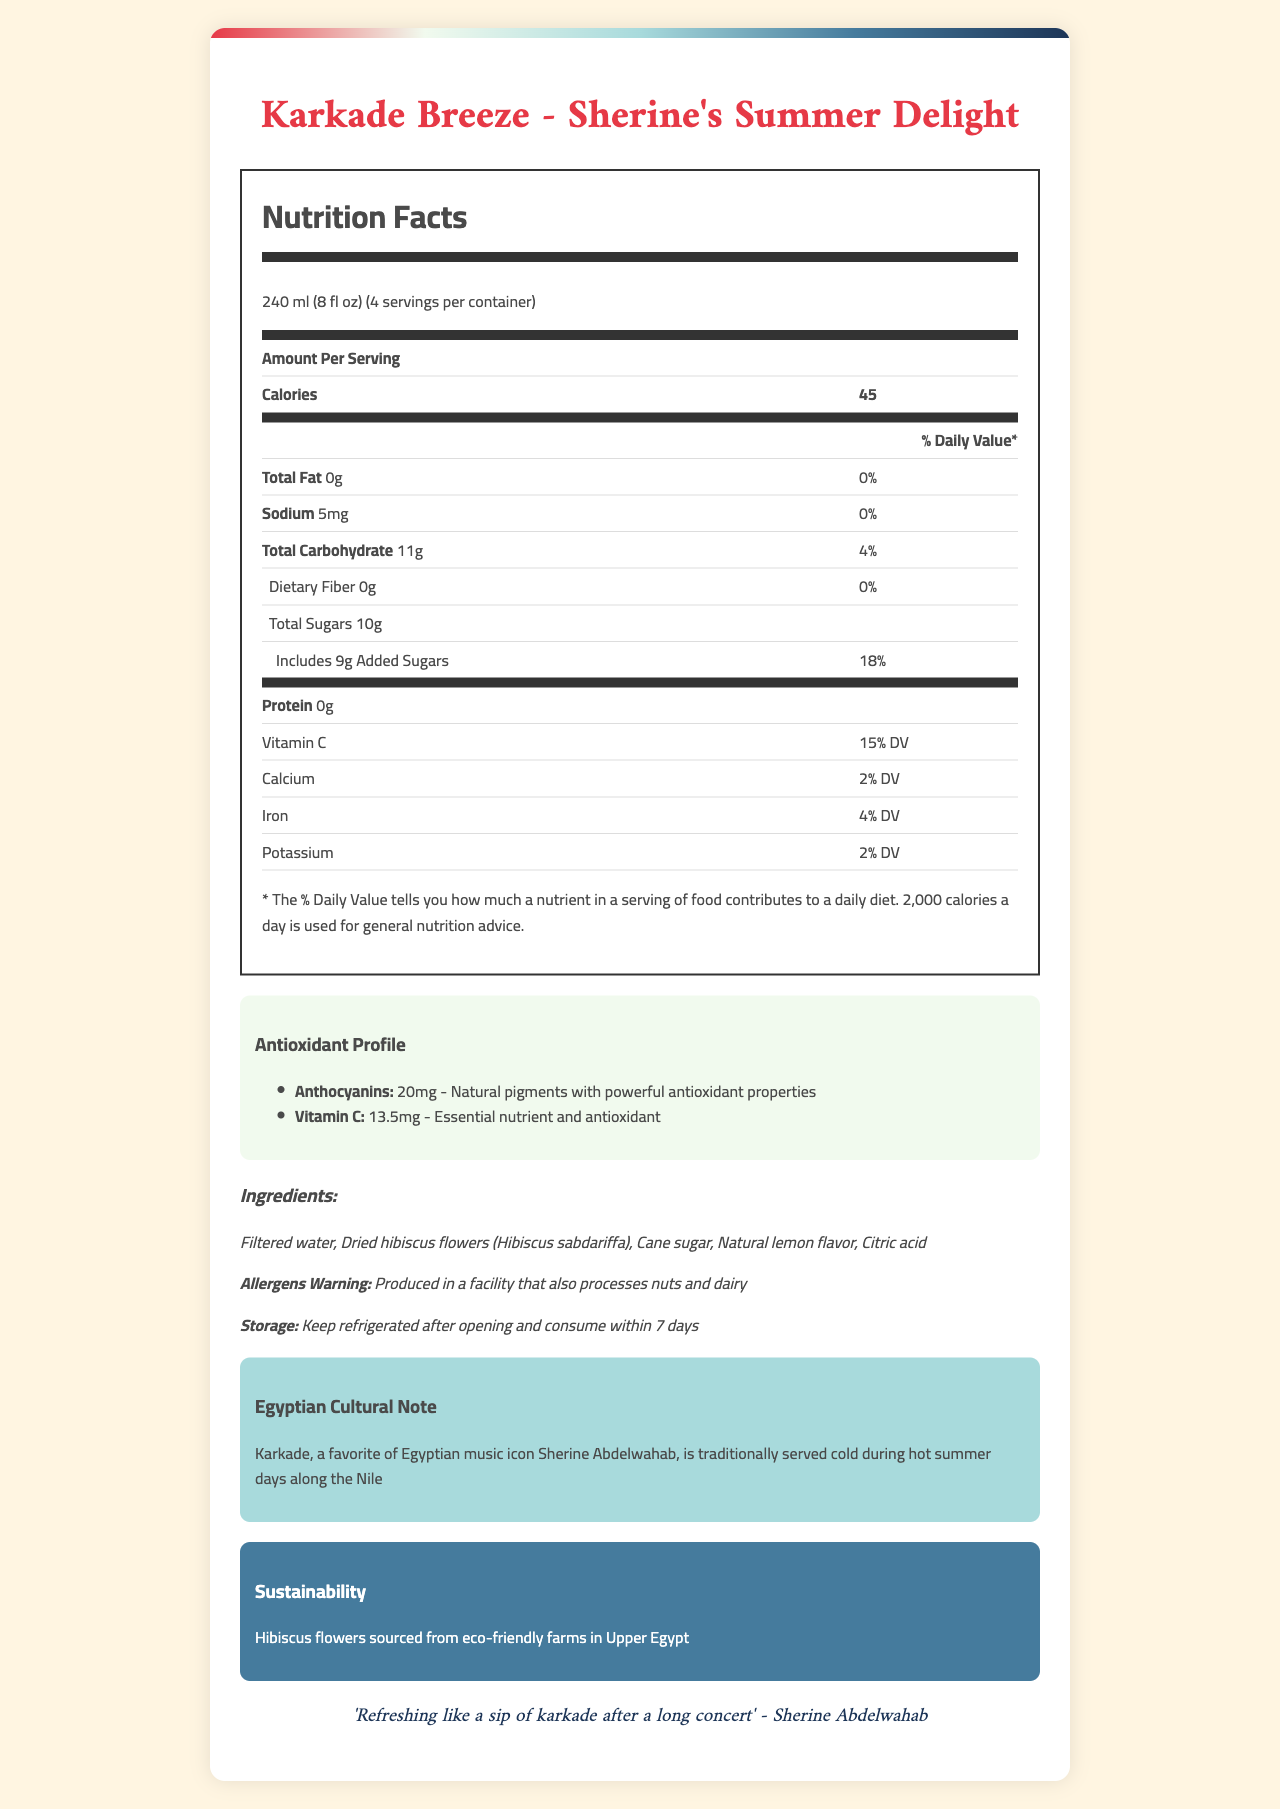What is the serving size of "Karkade Breeze - Sherine's Summer Delight"? The serving size is explicitly mentioned at the top of the Nutrition Facts table.
Answer: 240 ml (8 fl oz) How many calories are there per serving? The calories per serving are listed as 45.
Answer: 45 What percentage of the daily value of Vitamin C is in one serving? The Nutrition Facts list 15% DV for Vitamin C per serving.
Answer: 15% What are the main antioxidants found in "Karkade Breeze - Sherine's Summer Delight"? The 'Antioxidant Profile' section highlights Anthocyanins and Vitamin C.
Answer: Anthocyanins and Vitamin C How many grams of total sugars are in one serving? The Nutrition Facts table lists 10g under 'Total Sugars'.
Answer: 10g What are the ingredients of "Karkade Breeze - Sherine's Summer Delight"? The Ingredients section provides this detailed list.
Answer: Filtered water, Dried hibiscus flowers (Hibiscus sabdariffa), Cane sugar, Natural lemon flavor, Citric acid Does the product contain any protein? The Nutrition Facts state that the product contains 0g protein.
Answer: No What is the recommended storage instruction for the product? The storage instructions mention keeping the product refrigerated and consuming within 7 days of opening.
Answer: Keep refrigerated after opening and consume within 7 days Who is mentioned in the Egyptian Cultural Note as having a preference for karkade? The Egyptian Cultural Note specifically mentions Egyptian music icon Sherine Abdelwahab.
Answer: Sherine Abdelwahab What is the primary source of the hibiscus flowers used in the product? The Sustainability section states that the hibiscus flowers are sourced from eco-friendly farms in Upper Egypt.
Answer: Upper Egypt How much added sugar is there in one serving? The Nutrition Facts table lists 9g of added sugars per serving.
Answer: 9g Which of the following best describes Anthocyanins?
(A) A natural sweetener
(B) Natural pigments with antioxidant properties
(C) A type of protein
(D) An artificial coloring agent The Antioxidant Profile describes Anthocyanins as "Natural pigments with powerful antioxidant properties".
Answer: B How many servings are there per container?
(A) 2
(B) 3
(C) 4
(D) 5 The label indicates that there are 4 servings per container.
Answer: C Is the product produced in a facility that processes nuts and dairy? The Allergens Warning states that the product is produced in a facility that also processes nuts and dairy.
Answer: Yes Summarize the main features of "Karkade Breeze - Sherine's Summer Delight". The summary provides an overview of the product's key features, including nutritional information, antioxidants, ingredients, storage instructions, and sustainability information.
Answer: "Karkade Breeze - Sherine's Summer Delight" is a refreshing hibiscus tea with a serving size of 240 ml and 45 calories per serving. It contains 10g of total sugars per serving, including 9g of added sugars. The drink is rich in antioxidants, including Anthocyanins and Vitamin C, and contains 15% of the Daily Value of Vitamin C. Ingredients include filtered water, dried hibiscus flowers, cane sugar, natural lemon flavor, and citric acid. The product should be refrigerated after opening and consumed within 7 days. The hibiscus flowers are sourced from eco-friendly farms in Upper Egypt. What is Sherine Abdelwahab's quote related to karkade? The quote is given in the document under the 'musicInspirationQuote' section.
Answer: "Refreshing like a sip of karkade after a long concert" - Sherine Abdelwahab How long after opening the product should it be consumed? The storage instructions recommend consuming the product within 7 days after opening.
Answer: 7 days What is the source of the natural lemon flavor in the product? The document lists natural lemon flavor as an ingredient, but does not specify its source.
Answer: Not Enough Information 